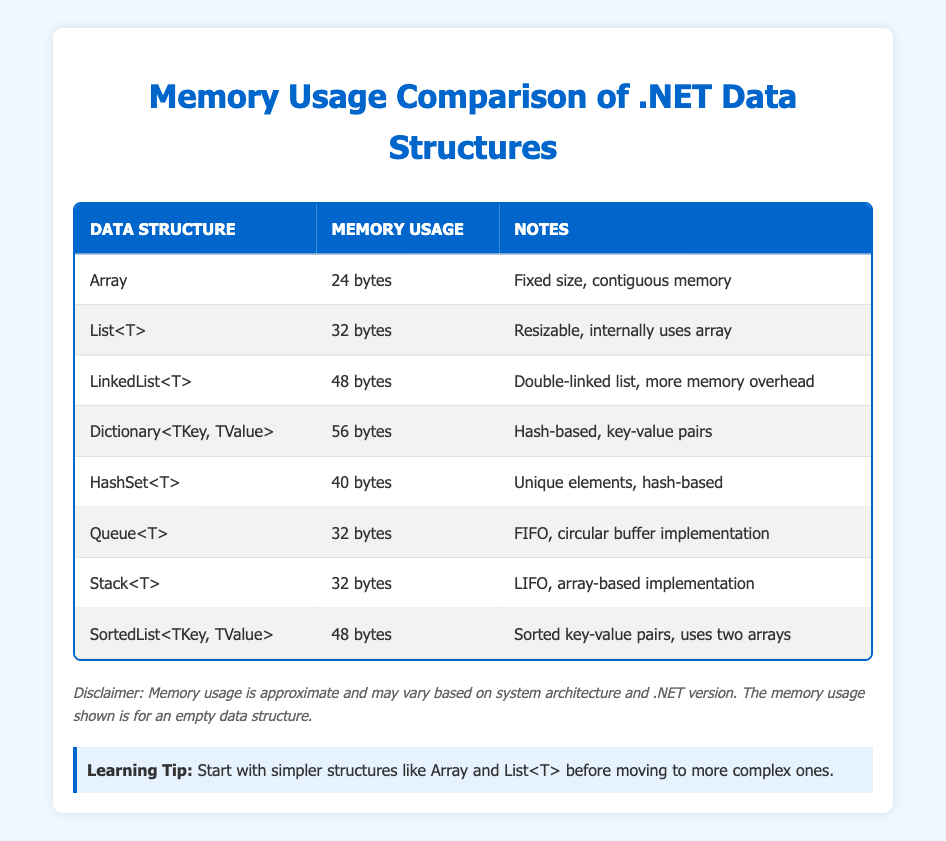What data structure has the highest memory usage? By examining the memory usage column, I identify that the Dictionary with 56 bytes has the highest memory usage compared to the other data structures.
Answer: Dictionary<TKey, TValue> What is the memory usage of an Array? The table directly shows that an Array has a memory usage of 24 bytes.
Answer: 24 bytes Is the memory usage of List<T> higher than that of HashSet<T>? By comparing the memory usage values, List<T> uses 32 bytes while HashSet<T> uses 40 bytes. Since 32 is less than 40, the statement is false.
Answer: No How much more memory does a LinkedList<T> use compared to an Array? The LinkedList<T> uses 48 bytes, and the Array uses 24 bytes. I calculate the difference: 48 - 24 = 24 bytes, which means LinkedList<T> uses 24 bytes more than Array.
Answer: 24 bytes What is the average memory usage of Queue<T>, Stack<T>, and List<T>? The memory usages for these three structures are 32 bytes for Queue<T>, 32 bytes for Stack<T>, and 32 bytes for List<T>. I sum them up: 32 + 32 + 32 = 96 bytes. Then, divide by the number of data structures (3) to find the average: 96 / 3 = 32 bytes.
Answer: 32 bytes Is it true that SortedList<TKey, TValue> uses less memory than LinkedList<T>? SortedList<TKey, TValue> uses 48 bytes, while LinkedList<T> also uses 48 bytes. Since both values are equal, the statement is true, as they do not exceed each other.
Answer: Yes How many bytes does HashSet<T> use compared to Dictionary<TKey, TValue>? HashSet<T> uses 40 bytes, while Dictionary<TKey, TValue> uses 56 bytes. The difference is 56 - 40 = 16 bytes, indicating that Dictionary<TKey, TValue> uses 16 bytes more.
Answer: 16 bytes Which data structure has the second highest memory usage? In looking at the memory usage values, after Dictionary’s 56 bytes, LinkedList<T> has the next highest value of 48 bytes, making it the second highest memory user.
Answer: LinkedList<T> How many data structures use the same amount of memory as Queue<T>? Examining the table, I find that Queue<T> uses 32 bytes. I see from the table that both List<T> and Stack<T> also use 32 bytes. Thus, there are two others that match this.
Answer: 2 